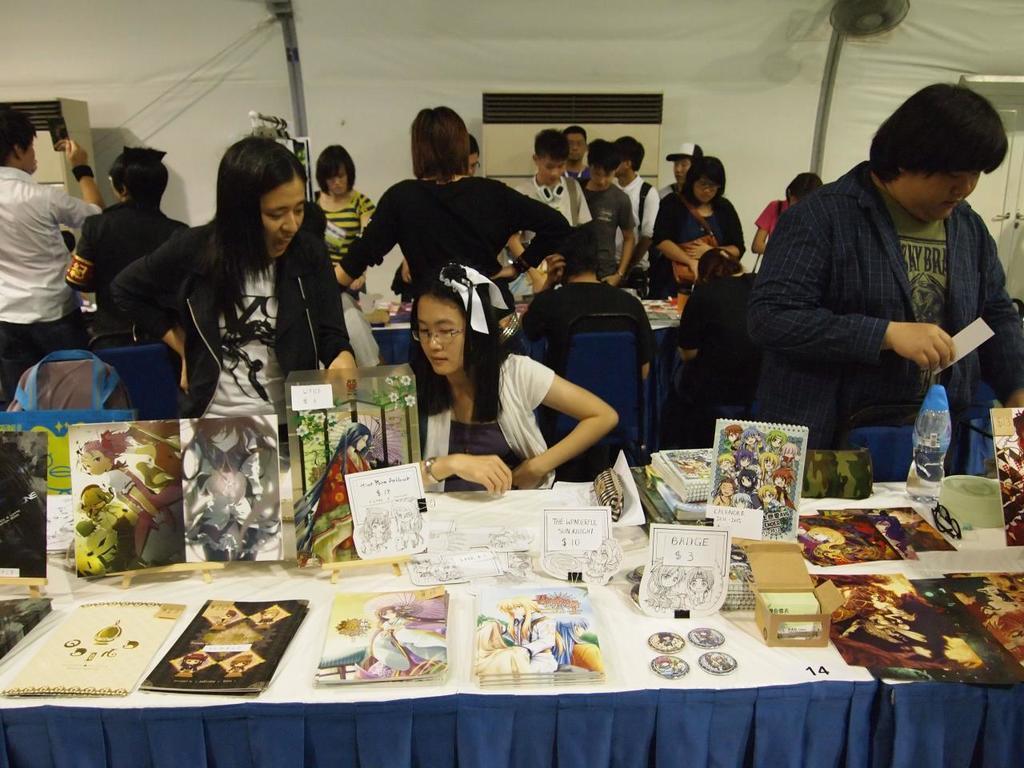Please provide a concise description of this image. In this picture I can see there are some people standing and a person sitting here and there is a table here and there are some objects placed here on the table. 